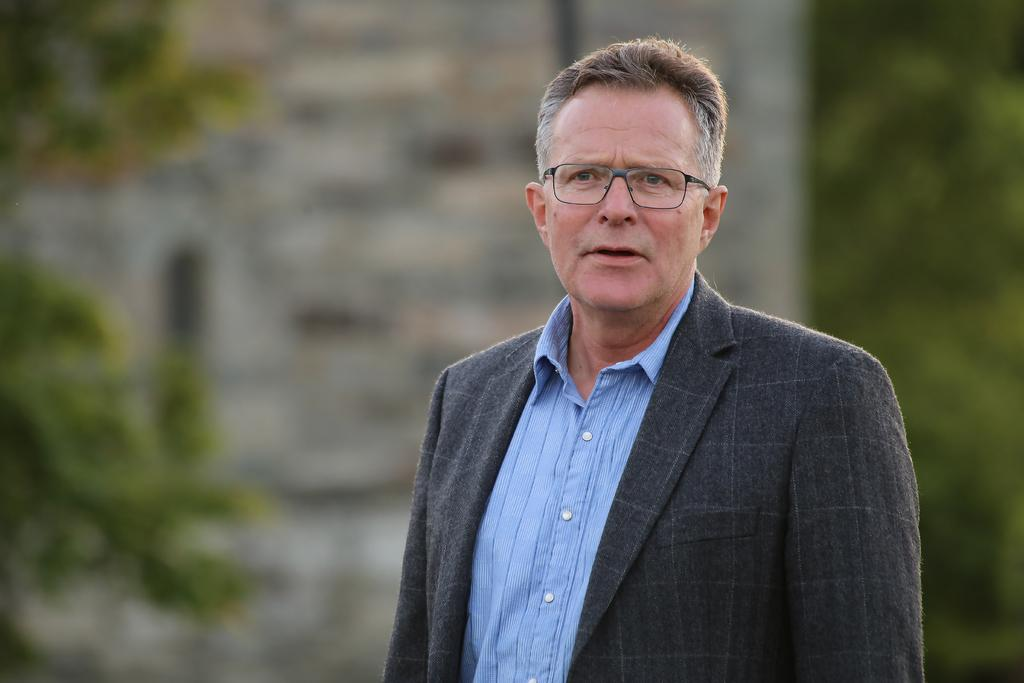Who or what is the main subject in the image? There is a person in the image. What can be seen behind the person? There are plants behind the person. How would you describe the background of the image? The background of the image is blurred. What type of list can be seen in the person's hand in the image? There is no list present in the image; the person's hands are not visible. 